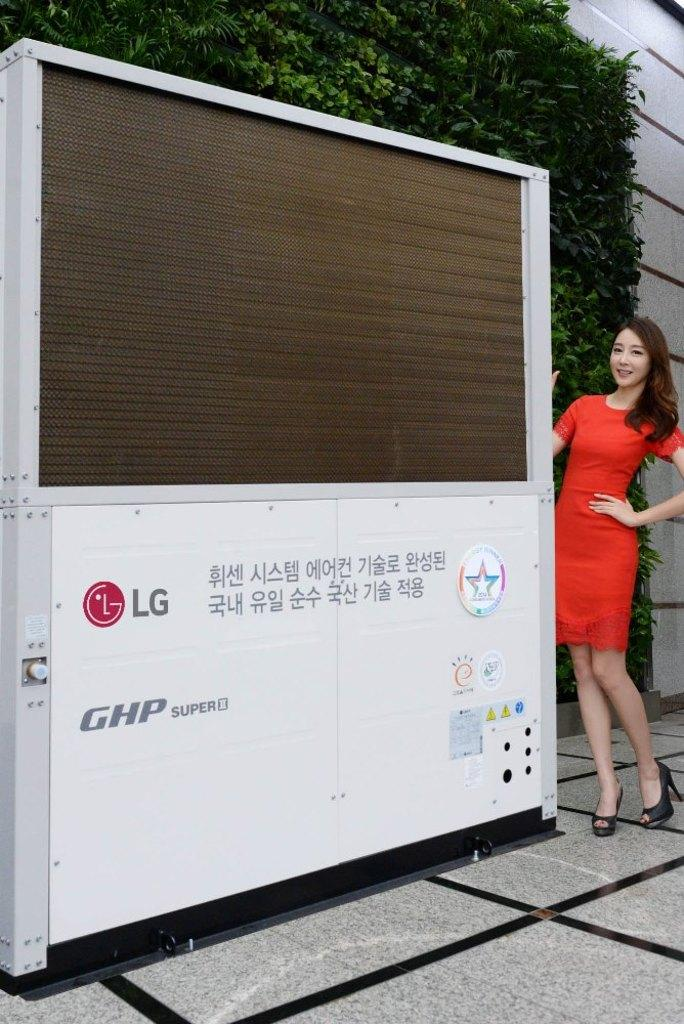Who is present on the right side of the image? There is a woman standing on the right side of the image. What object can be seen in the middle of the image? There is an electronic machine in the middle of the image. What type of natural elements can be seen in the background of the image? There are leaves visible in the background of the image. How does the woman stitch the leaves in the image? There is no stitching activity depicted in the image, and the woman is not interacting with the leaves. What type of damage can be seen on the electronic machine due to the earthquake in the image? There is no earthquake or damage to the electronic machine visible in the image. 